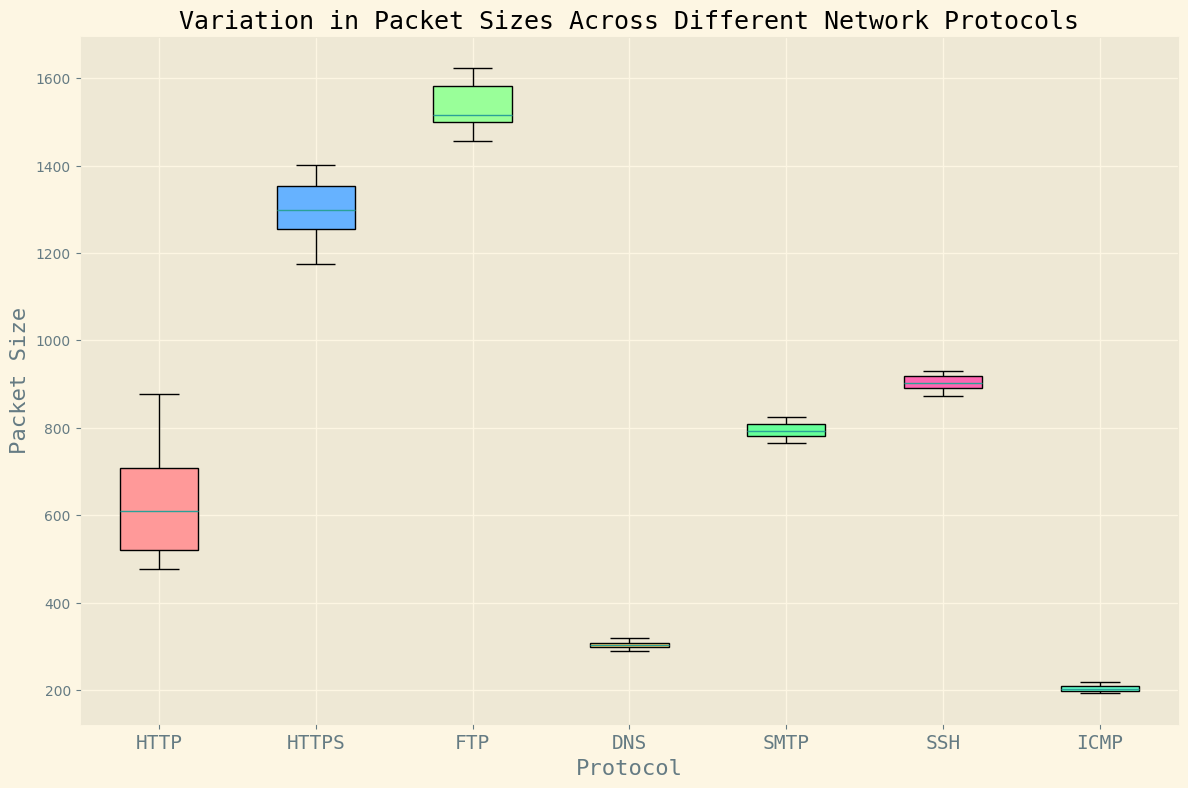Which protocol has the smallest median packet size? To determine which protocol has the smallest median packet size, one needs to look at the middle line within each box in the box plot. The middle line represents the median. By comparing the medians, it becomes clear that the ICMP protocol has the smallest median packet size.
Answer: ICMP What is the range of packet sizes for the FTP protocol? The range of packet sizes is calculated by subtracting the smallest packet size from the largest packet size within the given protocol's box-and-whisker plot. For the FTP protocol, observe the top and bottom whiskers to determine these values. The range is 1623 - 1457.
Answer: 166 Which protocol shows the greatest variation in packet sizes? To identify the protocol with the greatest variation, one should observe the length of the whiskers and the interquartile range (IQR, which is the height of the box) for each protocol in the box plot. The FTP protocol has the largest spread both in whisker length and the IQR.
Answer: FTP How does the median packet size of the HTTPS protocol compare to the HTTP protocol? The median packet size is represented by the middle line in each box. By comparing the median lines, it's observed that the median for HTTPS is higher than the median for HTTP.
Answer: HTTPS has a higher median Which protocol has the narrowest interquartile range (IQR) for packet sizes? The IQR is the height of the box in the box plot, representing the middle 50% of the data. By visually comparing the height of the boxes, DNS has the narrowest IQR.
Answer: DNS 